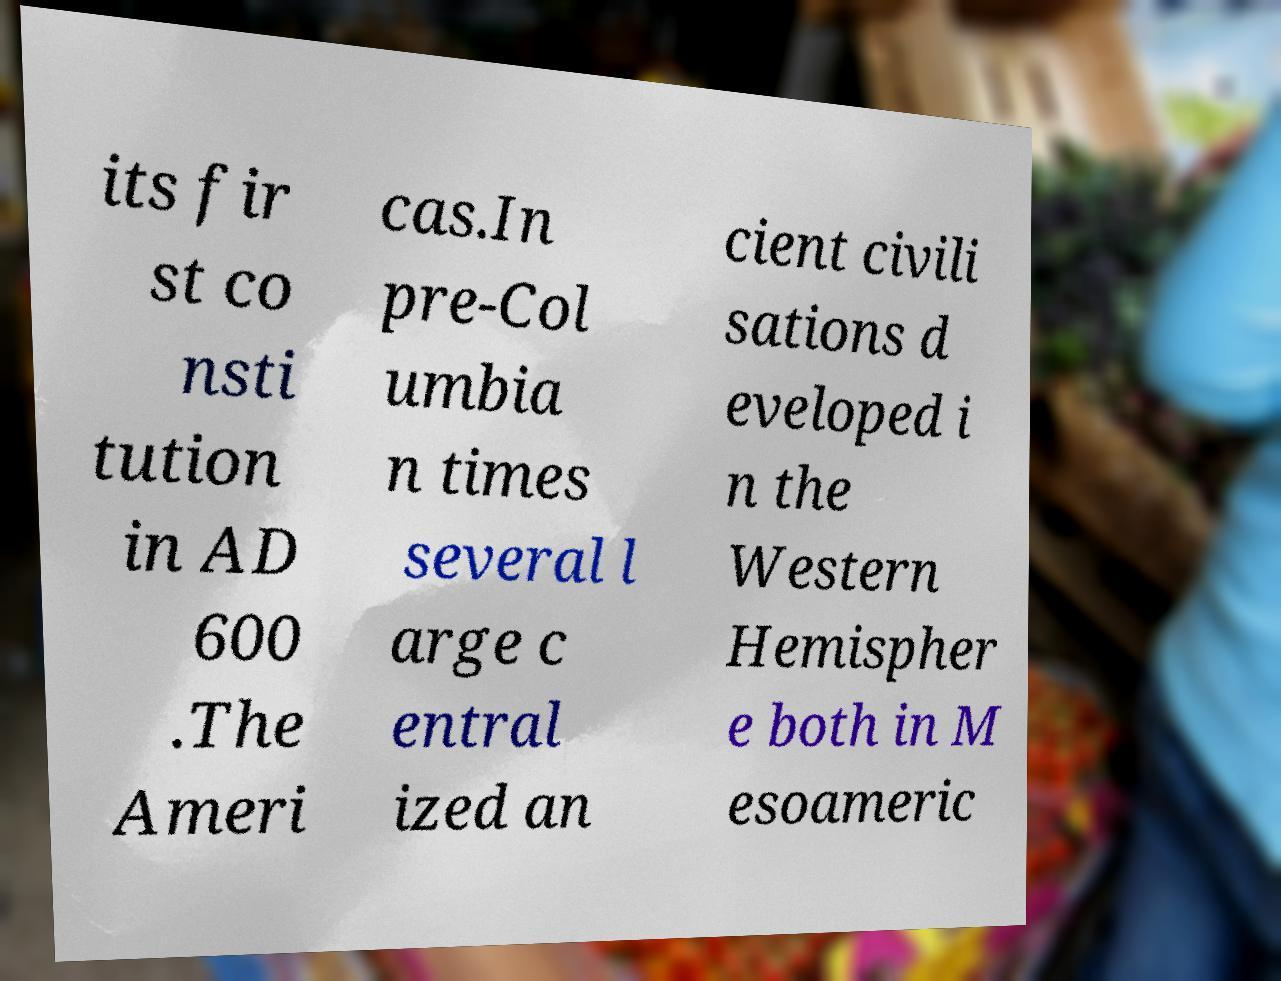For documentation purposes, I need the text within this image transcribed. Could you provide that? its fir st co nsti tution in AD 600 .The Ameri cas.In pre-Col umbia n times several l arge c entral ized an cient civili sations d eveloped i n the Western Hemispher e both in M esoameric 